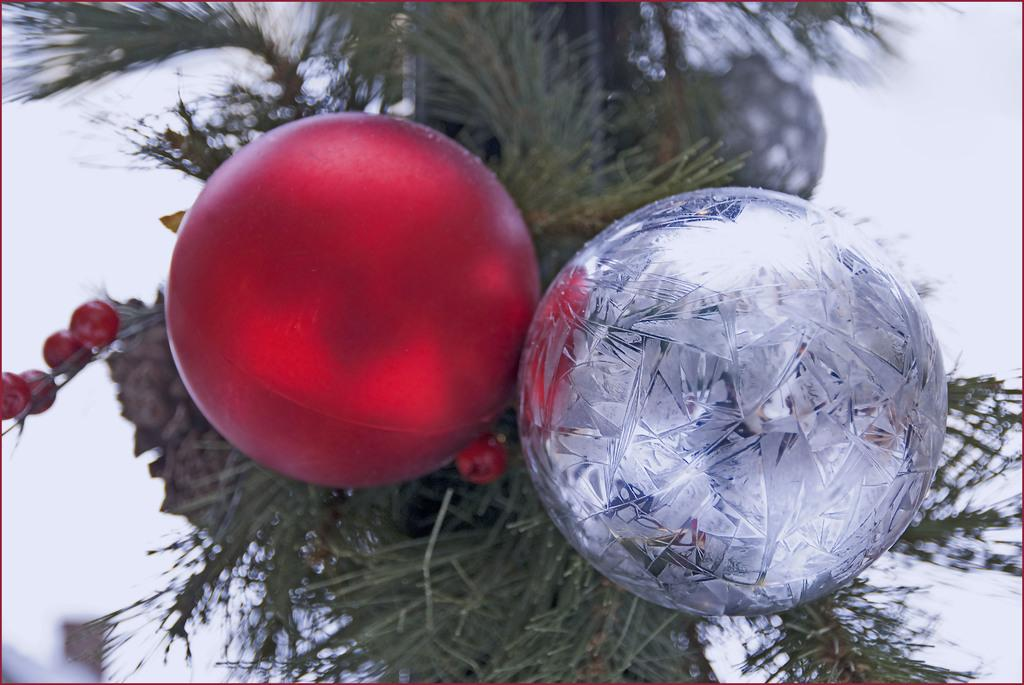What type of objects are featured in the image? There are decorative balls in the image. What colors are the decorative balls? The decorative balls are in red and silver colors. Where are the decorative balls located? The decorative balls are on a tree. Can you describe the background of the image? The background of the image is blurred. What type of vase is present in the image? There is no vase present in the image; it features decorative balls on a tree. What type of steel object can be seen in the image? There is no steel object present in the image. 